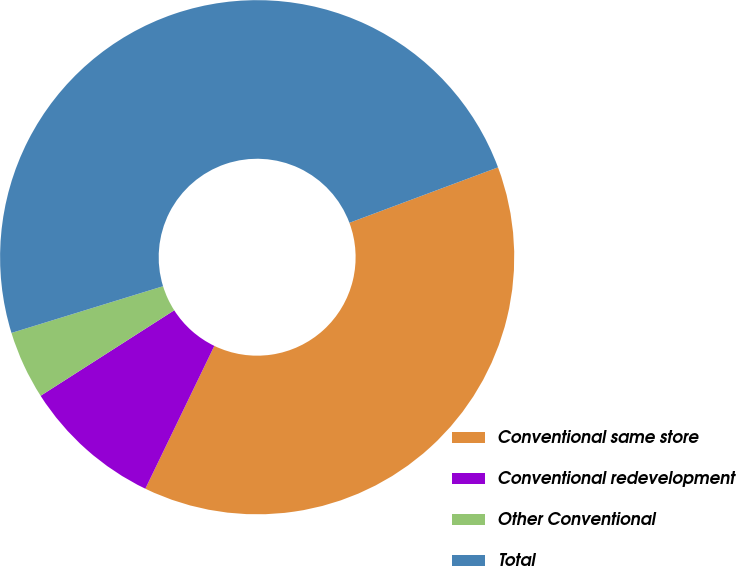Convert chart. <chart><loc_0><loc_0><loc_500><loc_500><pie_chart><fcel>Conventional same store<fcel>Conventional redevelopment<fcel>Other Conventional<fcel>Total<nl><fcel>37.84%<fcel>8.78%<fcel>4.3%<fcel>49.07%<nl></chart> 